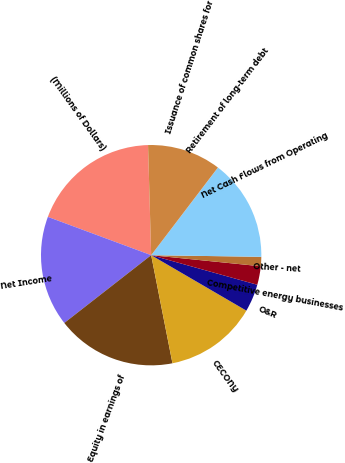<chart> <loc_0><loc_0><loc_500><loc_500><pie_chart><fcel>(Millions of Dollars)<fcel>Net Income<fcel>Equity in earnings of<fcel>CECONY<fcel>O&R<fcel>Competitive energy businesses<fcel>Other - net<fcel>Net Cash Flows from Operating<fcel>Retirement of long-term debt<fcel>Issuance of common shares for<nl><fcel>18.9%<fcel>16.2%<fcel>17.55%<fcel>13.51%<fcel>4.07%<fcel>2.72%<fcel>1.37%<fcel>14.86%<fcel>0.02%<fcel>10.81%<nl></chart> 